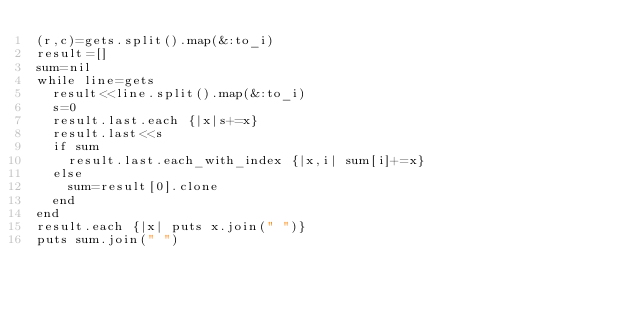Convert code to text. <code><loc_0><loc_0><loc_500><loc_500><_Ruby_>(r,c)=gets.split().map(&:to_i)
result=[]
sum=nil
while line=gets
  result<<line.split().map(&:to_i)
  s=0
  result.last.each {|x|s+=x}
  result.last<<s
  if sum
    result.last.each_with_index {|x,i| sum[i]+=x}
  else
    sum=result[0].clone
  end
end
result.each {|x| puts x.join(" ")}
puts sum.join(" ")</code> 